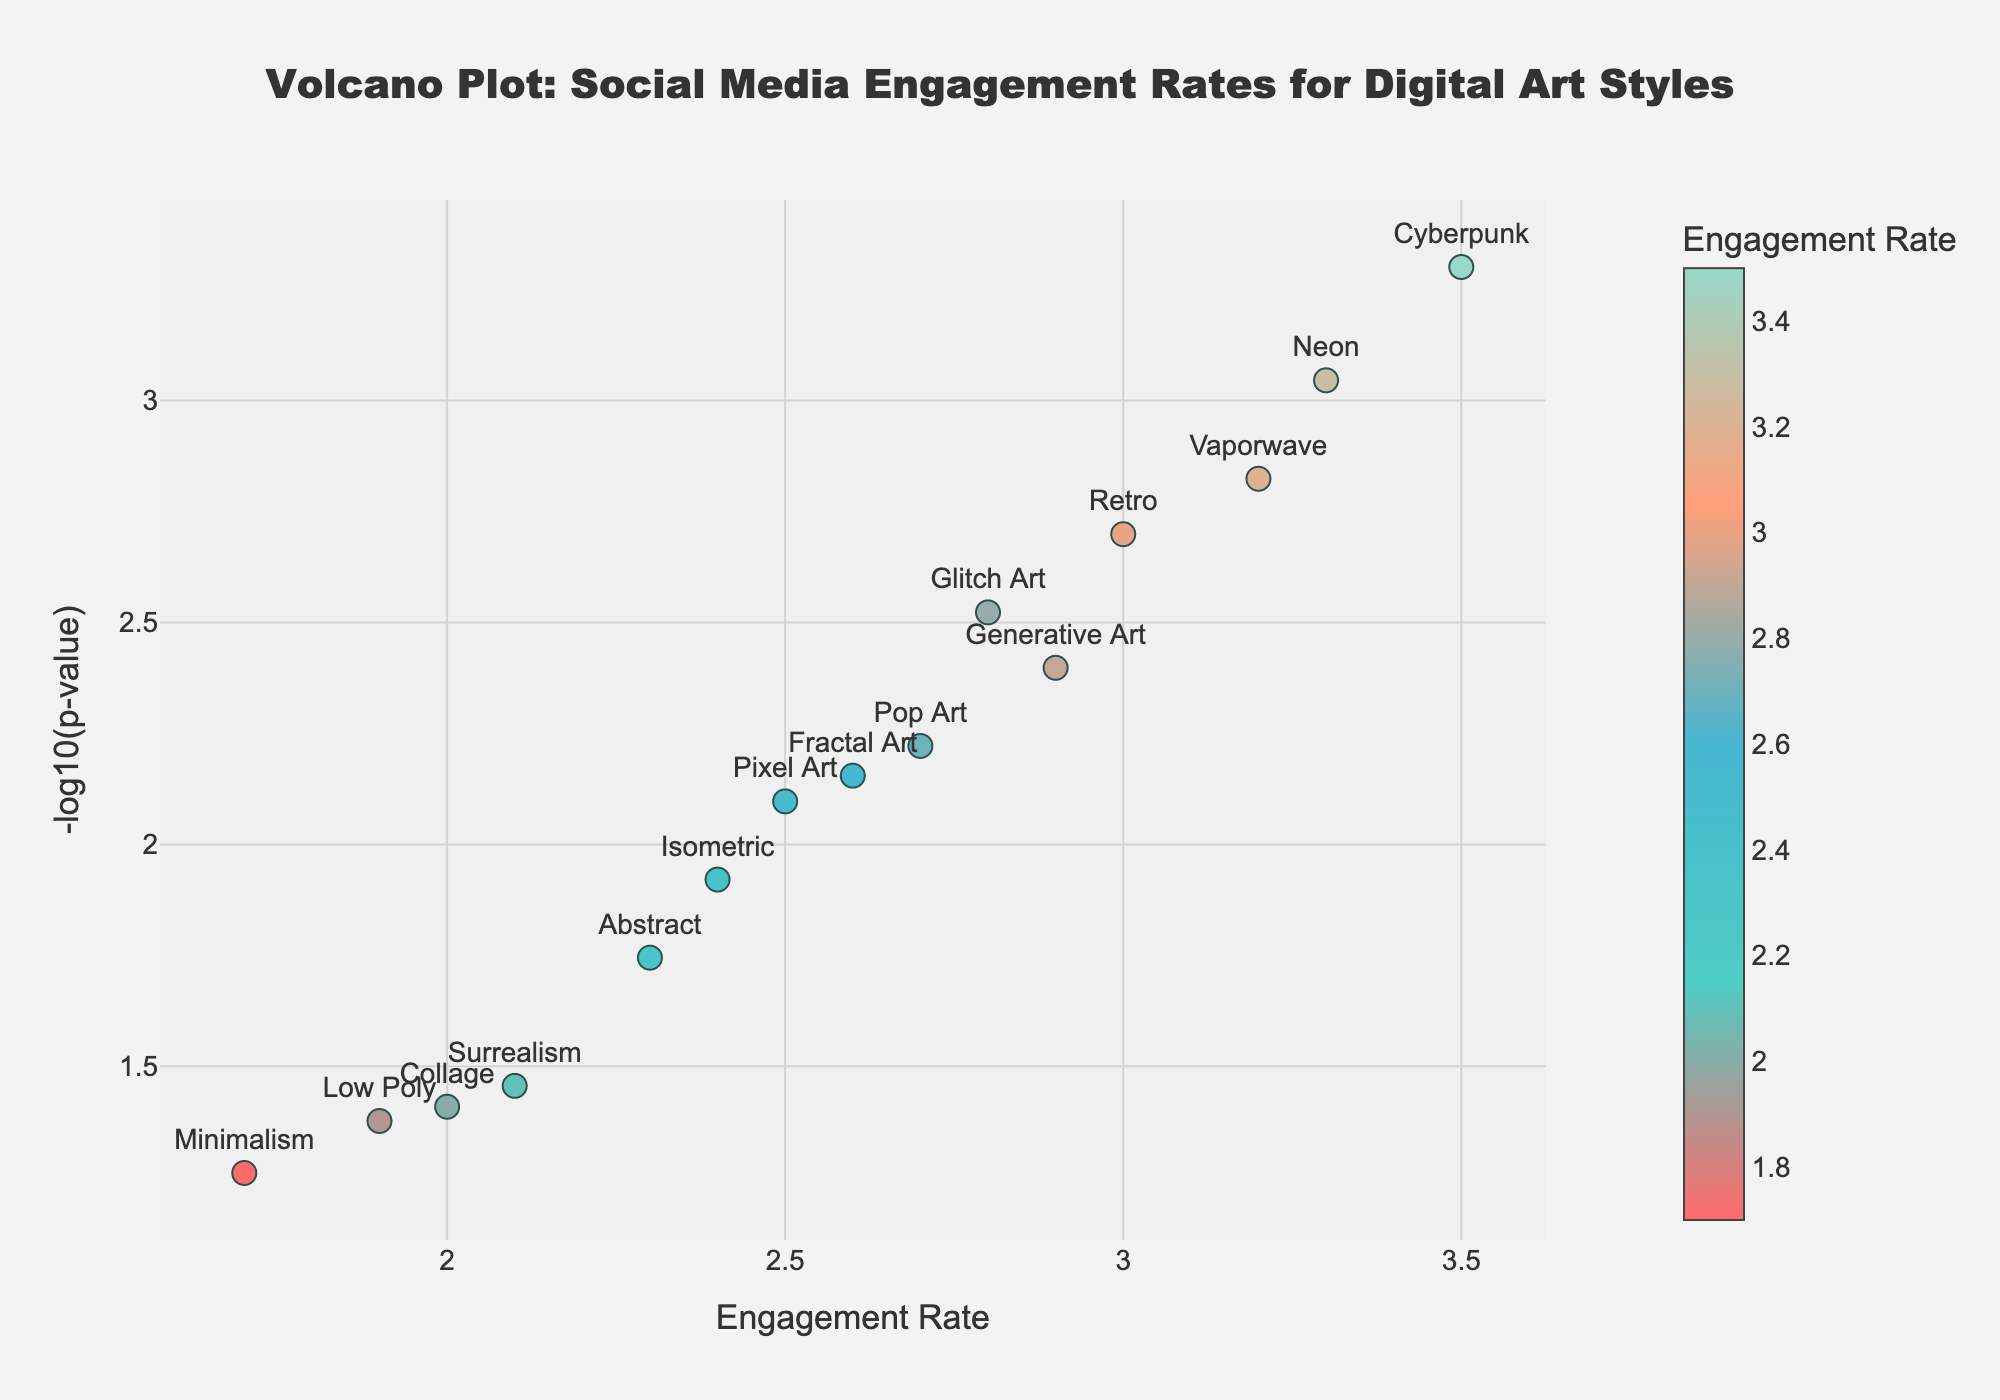what is the title of the plot? The title of the plot is displayed at the top of the figure, it reads "Volcano Plot: Social Media Engagement Rates for Digital Art Styles".
Answer: Volcano Plot: Social Media Engagement Rates for Digital Art Styles How is the engagement rate indicated in the plot? The engagement rate is indicated by the color of the markers on the plot. The color scale is shown on the right side of the plot's color bar, with darker colors representing lower engagement rates and lighter colors indicating higher engagement rates.
Answer: By the color of the markers Which art style has the lowest p-value? To find the lowest p-value, look for the highest value on the y-axis as -log10(p-value) is plotted on that axis. The highest point on the y-axis corresponds to "Cyberpunk".
Answer: Cyberpunk Which art style has the highest engagement rate? The highest engagement rate corresponds to the marker with the lightest shade. Look for the point with the highest x-axis value. The style is "Cyberpunk" with an engagement rate of 3.5.
Answer: Cyberpunk What does the y-axis represent? The y-axis represents the -log10 transformation of the p-value for the engagement rates of different digital art styles.
Answer: -log10(p-value) Identify and describe the marker for "Minimalism". The marker for "Minimalism" can be identified by its text label on the plot. It is positioned at an engagement rate of 1.7 (x-axis) and around 1.26 on the y-axis (-log10(p-value)). The marker's color is relatively darker compared to others, indicating a lower engagement rate.
Answer: Engagement Rate: 1.7, -log10(p-value): ~1.26, Darker color Compare the engagement rates between "Vaporwave" and "Glitch Art". Which one is higher and by how much? Find both markers on the plot and compare their x-axis values (Engagement Rate). "Vaporwave" has an engagement rate of 3.2 and "Glitch Art" has 2.8. The difference is 3.2 - 2.8 = 0.4.
Answer: Vaporwave is higher by 0.4 What is the median engagement rate among all the art styles? To find the median engagement rate, list all engagement rates in ascending order and find the middle value. Ordered Engagement Rates: 1.7, 1.9, 2.0, 2.1, 2.3, 2.4, 2.5, 2.6, 2.7, 2.8, 2.9, 3.0, 3.2, 3.3, 3.5. The median value is 2.6 (8th value in the list).
Answer: 2.6 What threshold p-value is implied by a -log10(p-value) of 2? A -log10(p-value) of 2 implies a p-value of 10^-2, which is 0.01.
Answer: 0.01 